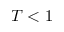Convert formula to latex. <formula><loc_0><loc_0><loc_500><loc_500>T < 1</formula> 